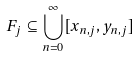<formula> <loc_0><loc_0><loc_500><loc_500>F _ { j } \subseteq \bigcup _ { n = 0 } ^ { \infty } [ x _ { n , j } , y _ { n , j } ]</formula> 